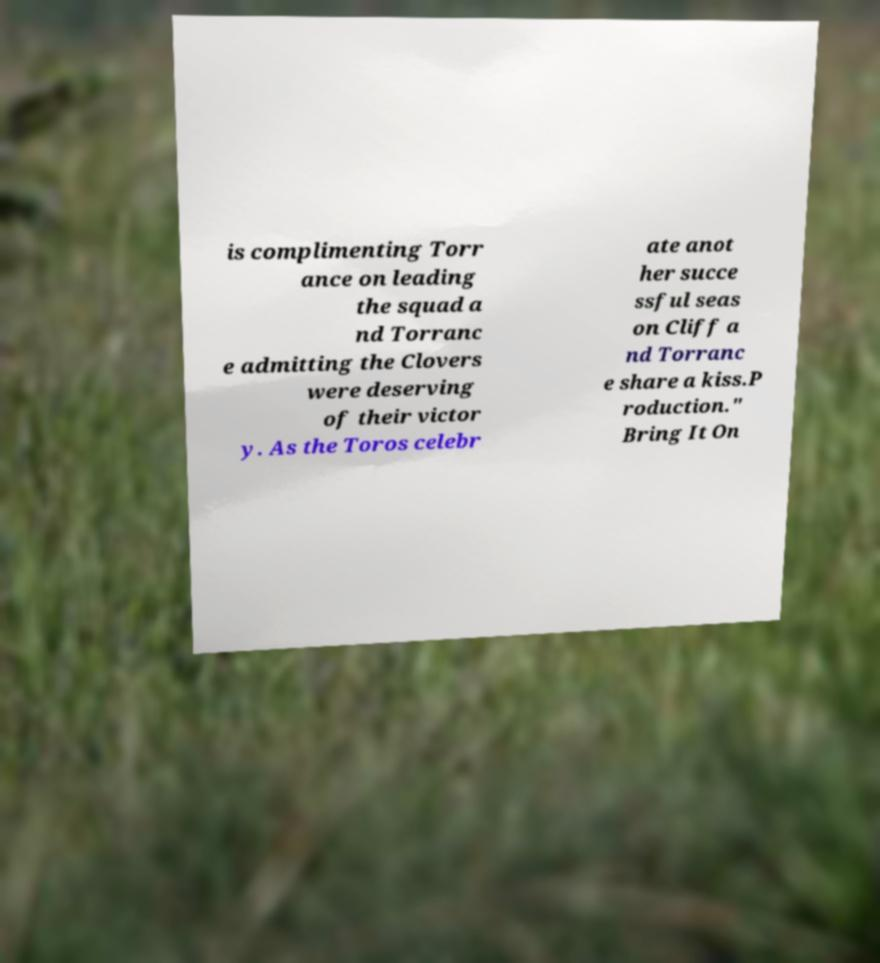Could you extract and type out the text from this image? is complimenting Torr ance on leading the squad a nd Torranc e admitting the Clovers were deserving of their victor y. As the Toros celebr ate anot her succe ssful seas on Cliff a nd Torranc e share a kiss.P roduction." Bring It On 